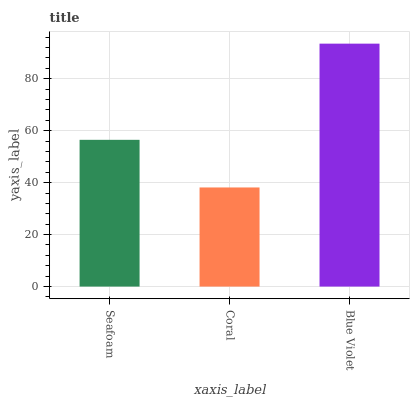Is Coral the minimum?
Answer yes or no. Yes. Is Blue Violet the maximum?
Answer yes or no. Yes. Is Blue Violet the minimum?
Answer yes or no. No. Is Coral the maximum?
Answer yes or no. No. Is Blue Violet greater than Coral?
Answer yes or no. Yes. Is Coral less than Blue Violet?
Answer yes or no. Yes. Is Coral greater than Blue Violet?
Answer yes or no. No. Is Blue Violet less than Coral?
Answer yes or no. No. Is Seafoam the high median?
Answer yes or no. Yes. Is Seafoam the low median?
Answer yes or no. Yes. Is Coral the high median?
Answer yes or no. No. Is Coral the low median?
Answer yes or no. No. 